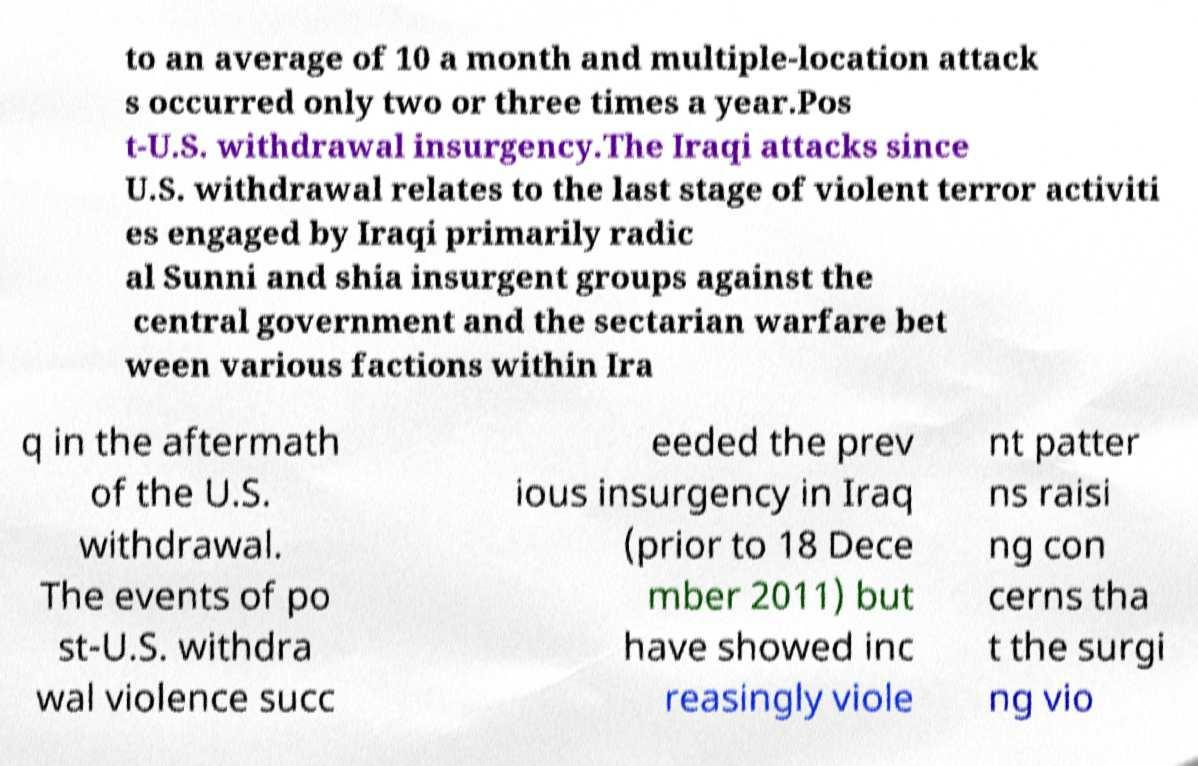Could you extract and type out the text from this image? to an average of 10 a month and multiple-location attack s occurred only two or three times a year.Pos t-U.S. withdrawal insurgency.The Iraqi attacks since U.S. withdrawal relates to the last stage of violent terror activiti es engaged by Iraqi primarily radic al Sunni and shia insurgent groups against the central government and the sectarian warfare bet ween various factions within Ira q in the aftermath of the U.S. withdrawal. The events of po st-U.S. withdra wal violence succ eeded the prev ious insurgency in Iraq (prior to 18 Dece mber 2011) but have showed inc reasingly viole nt patter ns raisi ng con cerns tha t the surgi ng vio 